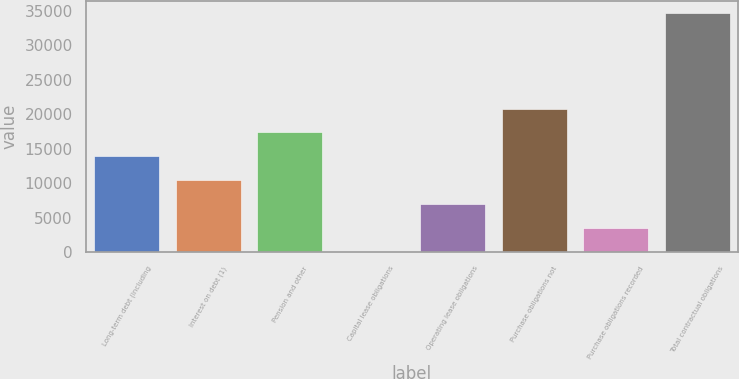<chart> <loc_0><loc_0><loc_500><loc_500><bar_chart><fcel>Long-term debt (including<fcel>Interest on debt (1)<fcel>Pension and other<fcel>Capital lease obligations<fcel>Operating lease obligations<fcel>Purchase obligations not<fcel>Purchase obligations recorded<fcel>Total contractual obligations<nl><fcel>13886.2<fcel>10416.4<fcel>17356<fcel>7<fcel>6946.6<fcel>20825.8<fcel>3476.8<fcel>34705<nl></chart> 